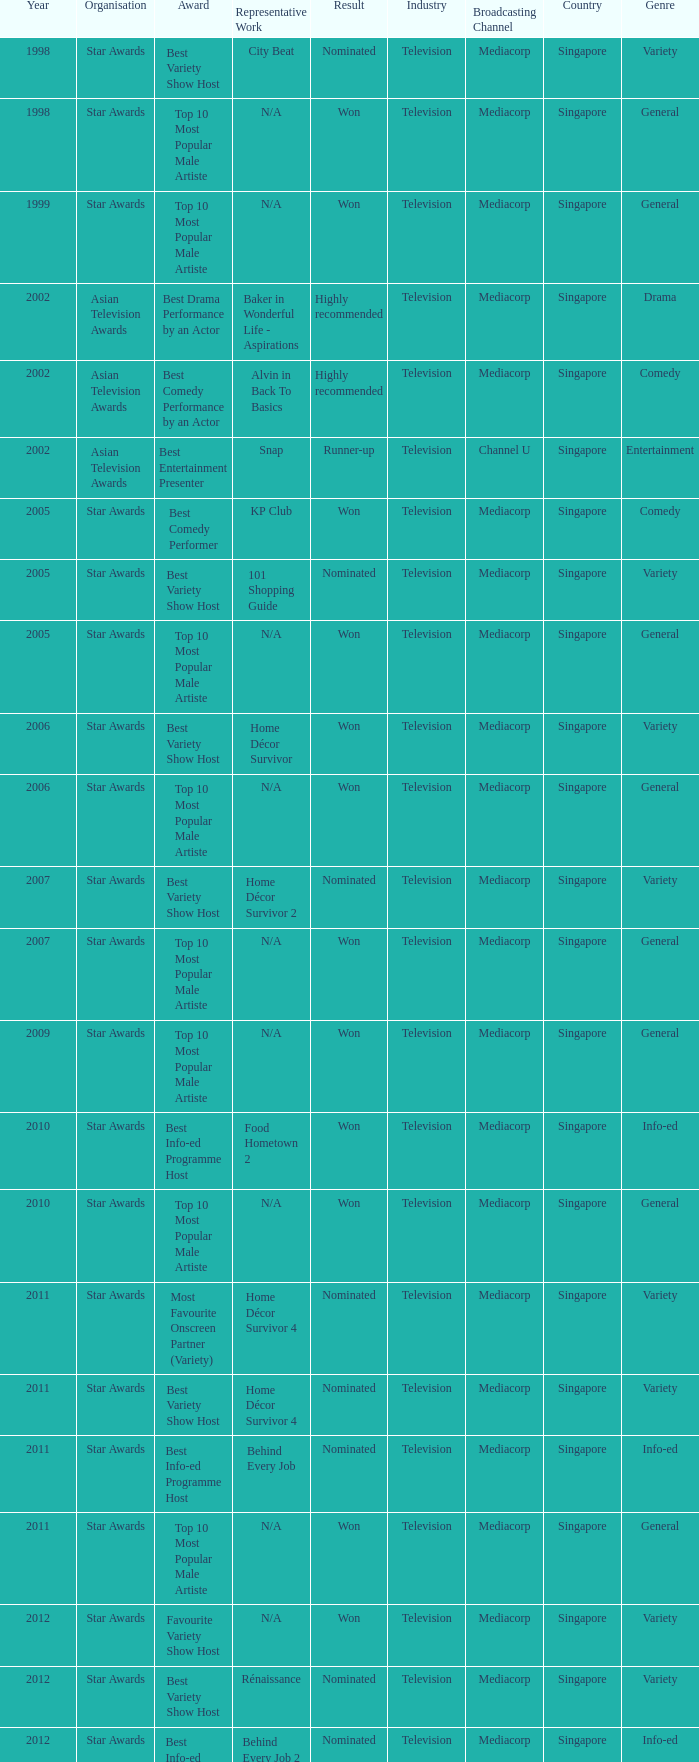What is the name of the Representative Work in a year later than 2005 with a Result of nominated, and an Award of best variety show host? Home Décor Survivor 2, Home Décor Survivor 4, Rénaissance, Jobs Around The World. I'm looking to parse the entire table for insights. Could you assist me with that? {'header': ['Year', 'Organisation', 'Award', 'Representative Work', 'Result', 'Industry', 'Broadcasting Channel', 'Country', 'Genre'], 'rows': [['1998', 'Star Awards', 'Best Variety Show Host', 'City Beat', 'Nominated', 'Television', 'Mediacorp', 'Singapore', 'Variety'], ['1998', 'Star Awards', 'Top 10 Most Popular Male Artiste', 'N/A', 'Won', 'Television', 'Mediacorp', 'Singapore', 'General'], ['1999', 'Star Awards', 'Top 10 Most Popular Male Artiste', 'N/A', 'Won', 'Television', 'Mediacorp', 'Singapore', 'General'], ['2002', 'Asian Television Awards', 'Best Drama Performance by an Actor', 'Baker in Wonderful Life - Aspirations', 'Highly recommended', 'Television', 'Mediacorp', 'Singapore', 'Drama'], ['2002', 'Asian Television Awards', 'Best Comedy Performance by an Actor', 'Alvin in Back To Basics', 'Highly recommended', 'Television', 'Mediacorp', 'Singapore', 'Comedy'], ['2002', 'Asian Television Awards', 'Best Entertainment Presenter', 'Snap', 'Runner-up', 'Television', 'Channel U', 'Singapore', 'Entertainment'], ['2005', 'Star Awards', 'Best Comedy Performer', 'KP Club', 'Won', 'Television', 'Mediacorp', 'Singapore', 'Comedy'], ['2005', 'Star Awards', 'Best Variety Show Host', '101 Shopping Guide', 'Nominated', 'Television', 'Mediacorp', 'Singapore', 'Variety'], ['2005', 'Star Awards', 'Top 10 Most Popular Male Artiste', 'N/A', 'Won', 'Television', 'Mediacorp', 'Singapore', 'General'], ['2006', 'Star Awards', 'Best Variety Show Host', 'Home Décor Survivor', 'Won', 'Television', 'Mediacorp', 'Singapore', 'Variety'], ['2006', 'Star Awards', 'Top 10 Most Popular Male Artiste', 'N/A', 'Won', 'Television', 'Mediacorp', 'Singapore', 'General'], ['2007', 'Star Awards', 'Best Variety Show Host', 'Home Décor Survivor 2', 'Nominated', 'Television', 'Mediacorp', 'Singapore', 'Variety'], ['2007', 'Star Awards', 'Top 10 Most Popular Male Artiste', 'N/A', 'Won', 'Television', 'Mediacorp', 'Singapore', 'General'], ['2009', 'Star Awards', 'Top 10 Most Popular Male Artiste', 'N/A', 'Won', 'Television', 'Mediacorp', 'Singapore', 'General'], ['2010', 'Star Awards', 'Best Info-ed Programme Host', 'Food Hometown 2', 'Won', 'Television', 'Mediacorp', 'Singapore', 'Info-ed'], ['2010', 'Star Awards', 'Top 10 Most Popular Male Artiste', 'N/A', 'Won', 'Television', 'Mediacorp', 'Singapore', 'General'], ['2011', 'Star Awards', 'Most Favourite Onscreen Partner (Variety)', 'Home Décor Survivor 4', 'Nominated', 'Television', 'Mediacorp', 'Singapore', 'Variety'], ['2011', 'Star Awards', 'Best Variety Show Host', 'Home Décor Survivor 4', 'Nominated', 'Television', 'Mediacorp', 'Singapore', 'Variety'], ['2011', 'Star Awards', 'Best Info-ed Programme Host', 'Behind Every Job', 'Nominated', 'Television', 'Mediacorp', 'Singapore', 'Info-ed'], ['2011', 'Star Awards', 'Top 10 Most Popular Male Artiste', 'N/A', 'Won', 'Television', 'Mediacorp', 'Singapore', 'General'], ['2012', 'Star Awards', 'Favourite Variety Show Host', 'N/A', 'Won', 'Television', 'Mediacorp', 'Singapore', 'Variety'], ['2012', 'Star Awards', 'Best Variety Show Host', 'Rénaissance', 'Nominated', 'Television', 'Mediacorp', 'Singapore', 'Variety'], ['2012', 'Star Awards', 'Best Info-ed Programme Host', 'Behind Every Job 2', 'Nominated', 'Television', 'Mediacorp', 'Singapore', 'Info-ed'], ['2012', 'Star Awards', 'Top 10 Most Popular Male Artiste', 'N/A', 'Won', 'Television', 'Mediacorp', 'Singapore', 'General'], ['2013', 'Star Awards', 'Favourite Variety Show Host', 'S.N.A.P. 熠熠星光总动员', 'Won', 'Television', 'Channel U', 'Singapore', 'Variety'], ['2013', 'Star Awards', 'Top 10 Most Popular Male Artiste', 'N/A', 'Won', 'Television', 'Mediacorp', 'Singapore', 'General'], ['2013', 'Star Awards', 'Best Info-Ed Programme Host', 'Makan Unlimited', 'Nominated', 'Television', 'Mediacorp', 'Singapore', 'Info-ed'], ['2013', 'Star Awards', 'Best Variety Show Host', 'Jobs Around The World', 'Nominated', 'Television', 'Mediacorp', 'Singapore', 'Variety']]} 